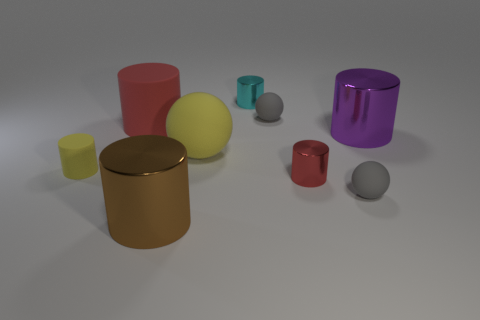How big is the brown thing?
Offer a very short reply. Large. How many small rubber cylinders have the same color as the big ball?
Make the answer very short. 1. There is a metal cylinder in front of the tiny rubber ball that is in front of the purple shiny cylinder; are there any big red cylinders that are left of it?
Your response must be concise. Yes. There is a purple metal object that is the same size as the red matte cylinder; what shape is it?
Your answer should be very brief. Cylinder. How many big things are brown shiny things or rubber spheres?
Make the answer very short. 2. What is the color of the large cylinder that is the same material as the large sphere?
Your answer should be compact. Red. There is a red object behind the yellow matte cylinder; is it the same shape as the big metallic thing on the left side of the small cyan metal object?
Offer a very short reply. Yes. How many matte things are small purple cubes or big cylinders?
Provide a succinct answer. 1. There is a small cylinder that is the same color as the large matte cylinder; what is it made of?
Your answer should be compact. Metal. Is there any other thing that has the same shape as the tiny cyan shiny object?
Provide a succinct answer. Yes. 